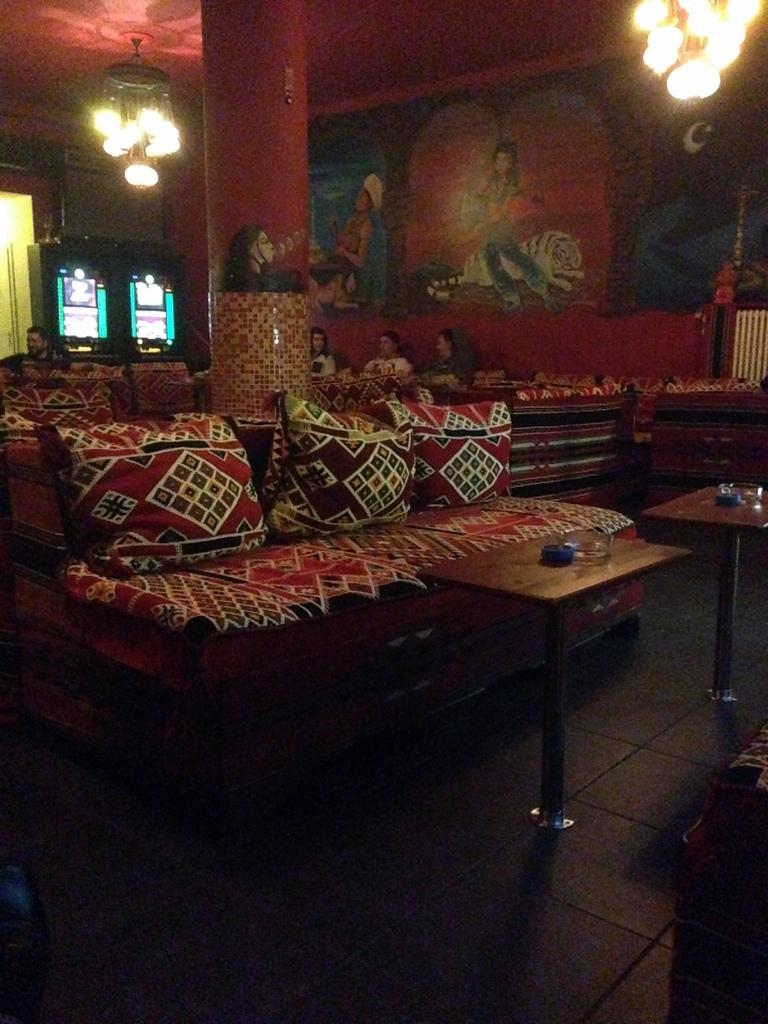What type of furniture is present in the image? There is a sofa and tables in the image. What kind of lighting is featured in the image? There is a chandelier light in the image. Who is present in the image? There are people seated on the sofa. What type of fork is being used by the people seated on the sofa in the image? There is no fork present in the image; the people are seated on a sofa without any visible utensils. 